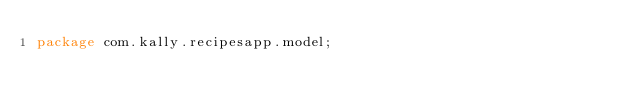Convert code to text. <code><loc_0><loc_0><loc_500><loc_500><_Java_>package com.kally.recipesapp.model;
</code> 